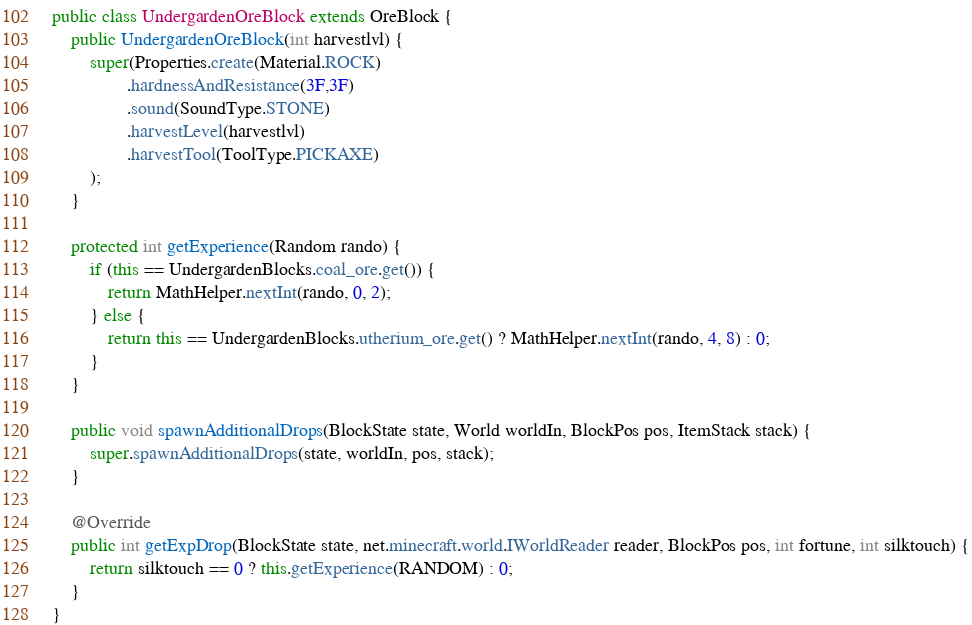Convert code to text. <code><loc_0><loc_0><loc_500><loc_500><_Java_>public class UndergardenOreBlock extends OreBlock {
    public UndergardenOreBlock(int harvestlvl) {
        super(Properties.create(Material.ROCK)
                .hardnessAndResistance(3F,3F)
                .sound(SoundType.STONE)
                .harvestLevel(harvestlvl)
                .harvestTool(ToolType.PICKAXE)
        );
    }

    protected int getExperience(Random rando) {
        if (this == UndergardenBlocks.coal_ore.get()) {
            return MathHelper.nextInt(rando, 0, 2);
        } else {
            return this == UndergardenBlocks.utherium_ore.get() ? MathHelper.nextInt(rando, 4, 8) : 0;
        }
    }

    public void spawnAdditionalDrops(BlockState state, World worldIn, BlockPos pos, ItemStack stack) {
        super.spawnAdditionalDrops(state, worldIn, pos, stack);
    }

    @Override
    public int getExpDrop(BlockState state, net.minecraft.world.IWorldReader reader, BlockPos pos, int fortune, int silktouch) {
        return silktouch == 0 ? this.getExperience(RANDOM) : 0;
    }
}
</code> 